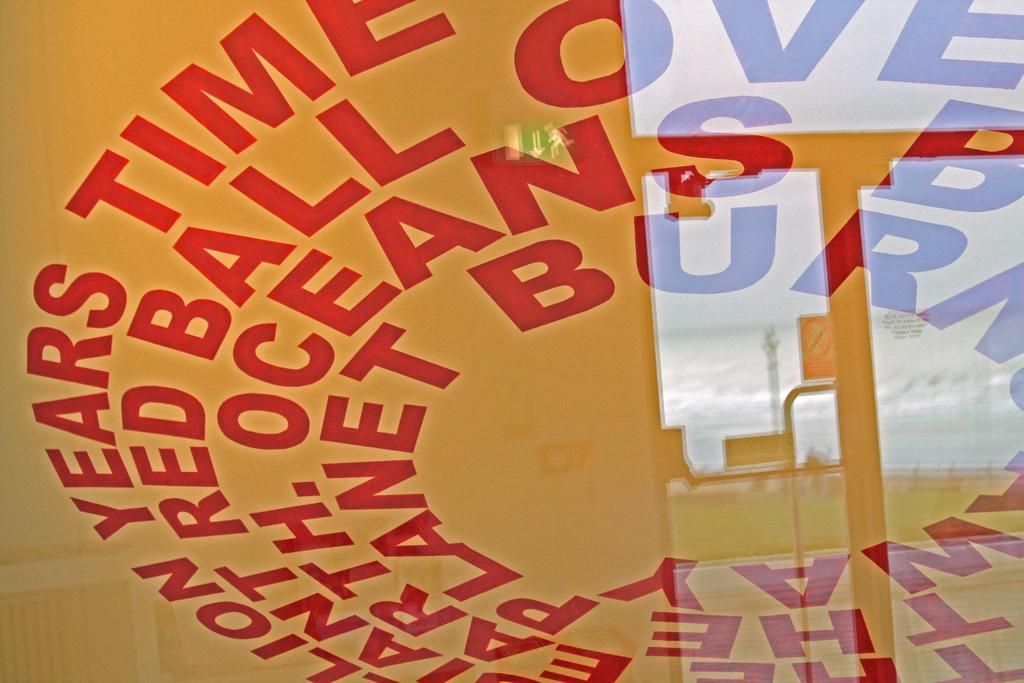<image>
Share a concise interpretation of the image provided. Words in red with years and time are in a circle. 